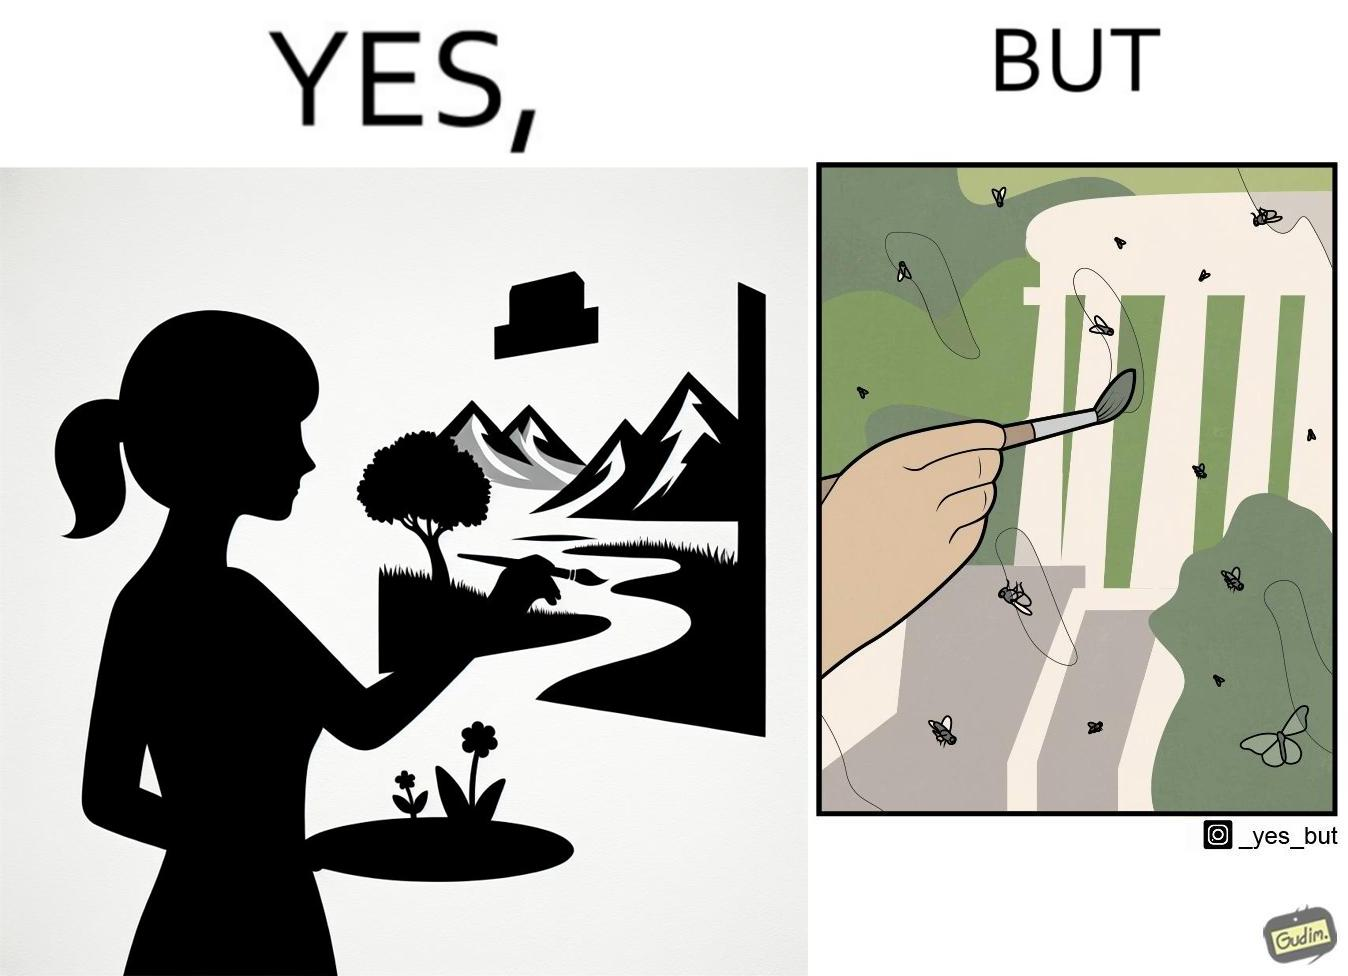What is the satirical meaning behind this image? The images are funny since they show how a peaceful sight like a woman painting a natural scenery looks good only from afar. When looked closely we can see details like flies on the painting which make us uneasy and the scene is not so good to look at anymore. 